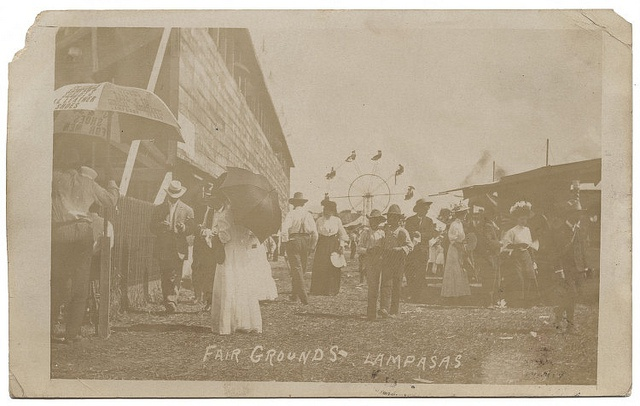Describe the objects in this image and their specific colors. I can see people in white, gray, and tan tones, people in white, tan, and gray tones, umbrella in white and tan tones, people in white, gray, and tan tones, and umbrella in white, gray, and tan tones in this image. 